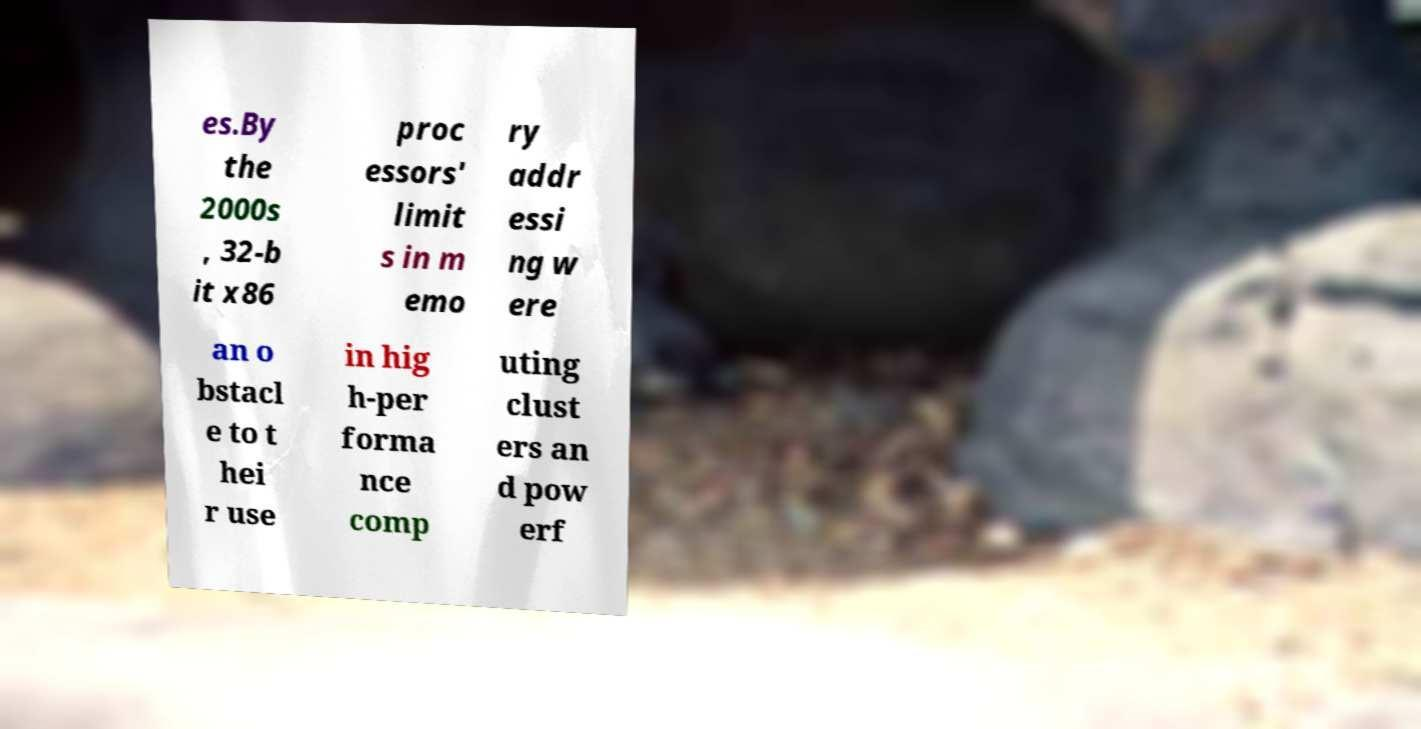Could you extract and type out the text from this image? es.By the 2000s , 32-b it x86 proc essors' limit s in m emo ry addr essi ng w ere an o bstacl e to t hei r use in hig h-per forma nce comp uting clust ers an d pow erf 